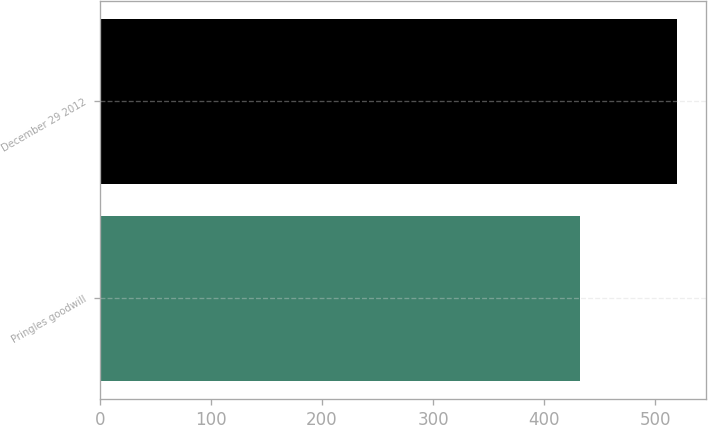Convert chart. <chart><loc_0><loc_0><loc_500><loc_500><bar_chart><fcel>Pringles goodwill<fcel>December 29 2012<nl><fcel>432<fcel>520<nl></chart> 